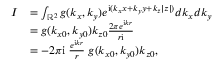Convert formula to latex. <formula><loc_0><loc_0><loc_500><loc_500>\begin{array} { r l } { I } & { = \int _ { \mathbb { R } ^ { 2 } } g ( k _ { x } , k _ { y } ) e ^ { i ( k _ { x } x + k _ { y } y + k _ { z } | z | ) } d k _ { x } d k _ { y } } \\ & { = g ( k _ { x 0 } , k _ { y 0 } ) k _ { z 0 } \frac { 2 \pi e ^ { i k r } } { r i } } \\ & { = - 2 \pi i \, \frac { e ^ { i k r } } { r } \, g ( k _ { x 0 } , k _ { y 0 } ) k _ { z 0 } , } \end{array}</formula> 